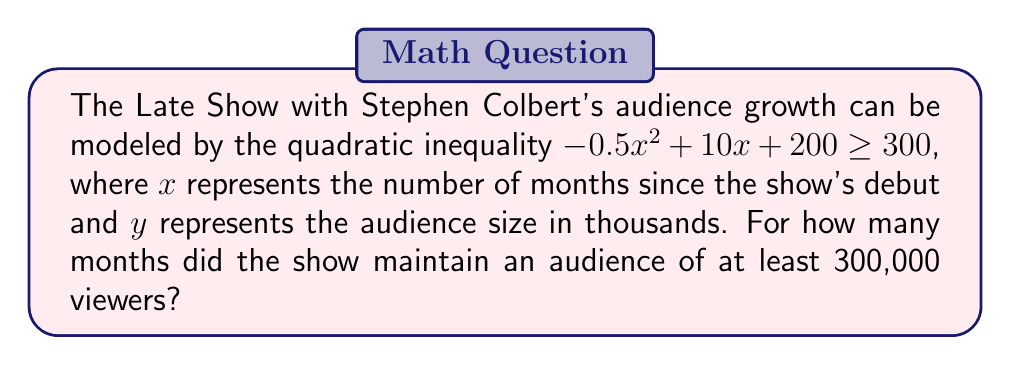Can you solve this math problem? Let's approach this step-by-step:

1) The inequality we need to solve is:
   $-0.5x^2 + 10x + 200 \geq 300$

2) Rearrange the inequality:
   $-0.5x^2 + 10x - 100 \geq 0$

3) This is a quadratic inequality. To solve it, we first need to find the roots of the corresponding quadratic equation:
   $-0.5x^2 + 10x - 100 = 0$

4) We can solve this using the quadratic formula: $x = \frac{-b \pm \sqrt{b^2 - 4ac}}{2a}$
   Where $a = -0.5$, $b = 10$, and $c = -100$

5) Substituting these values:
   $x = \frac{-10 \pm \sqrt{100 - 4(-0.5)(-100)}}{2(-0.5)}$
   $= \frac{-10 \pm \sqrt{100 - 200}}{-1}$
   $= \frac{-10 \pm \sqrt{-100}}{-1}$
   $= \frac{-10 \pm 10i}{-1}$

6) The roots are complex, which means the parabola never crosses the x-axis. 

7) Since the coefficient of $x^2$ is negative, the parabola opens downward. This means the inequality is satisfied for all real values of $x$.

8) In the context of the problem, this means the show maintained an audience of at least 300,000 viewers for its entire run.

9) As the question asks for the number of months, and $x$ represents months since the show's debut, we can say the show maintained this audience for all months, which is effectively indefinite.
Answer: Indefinitely 